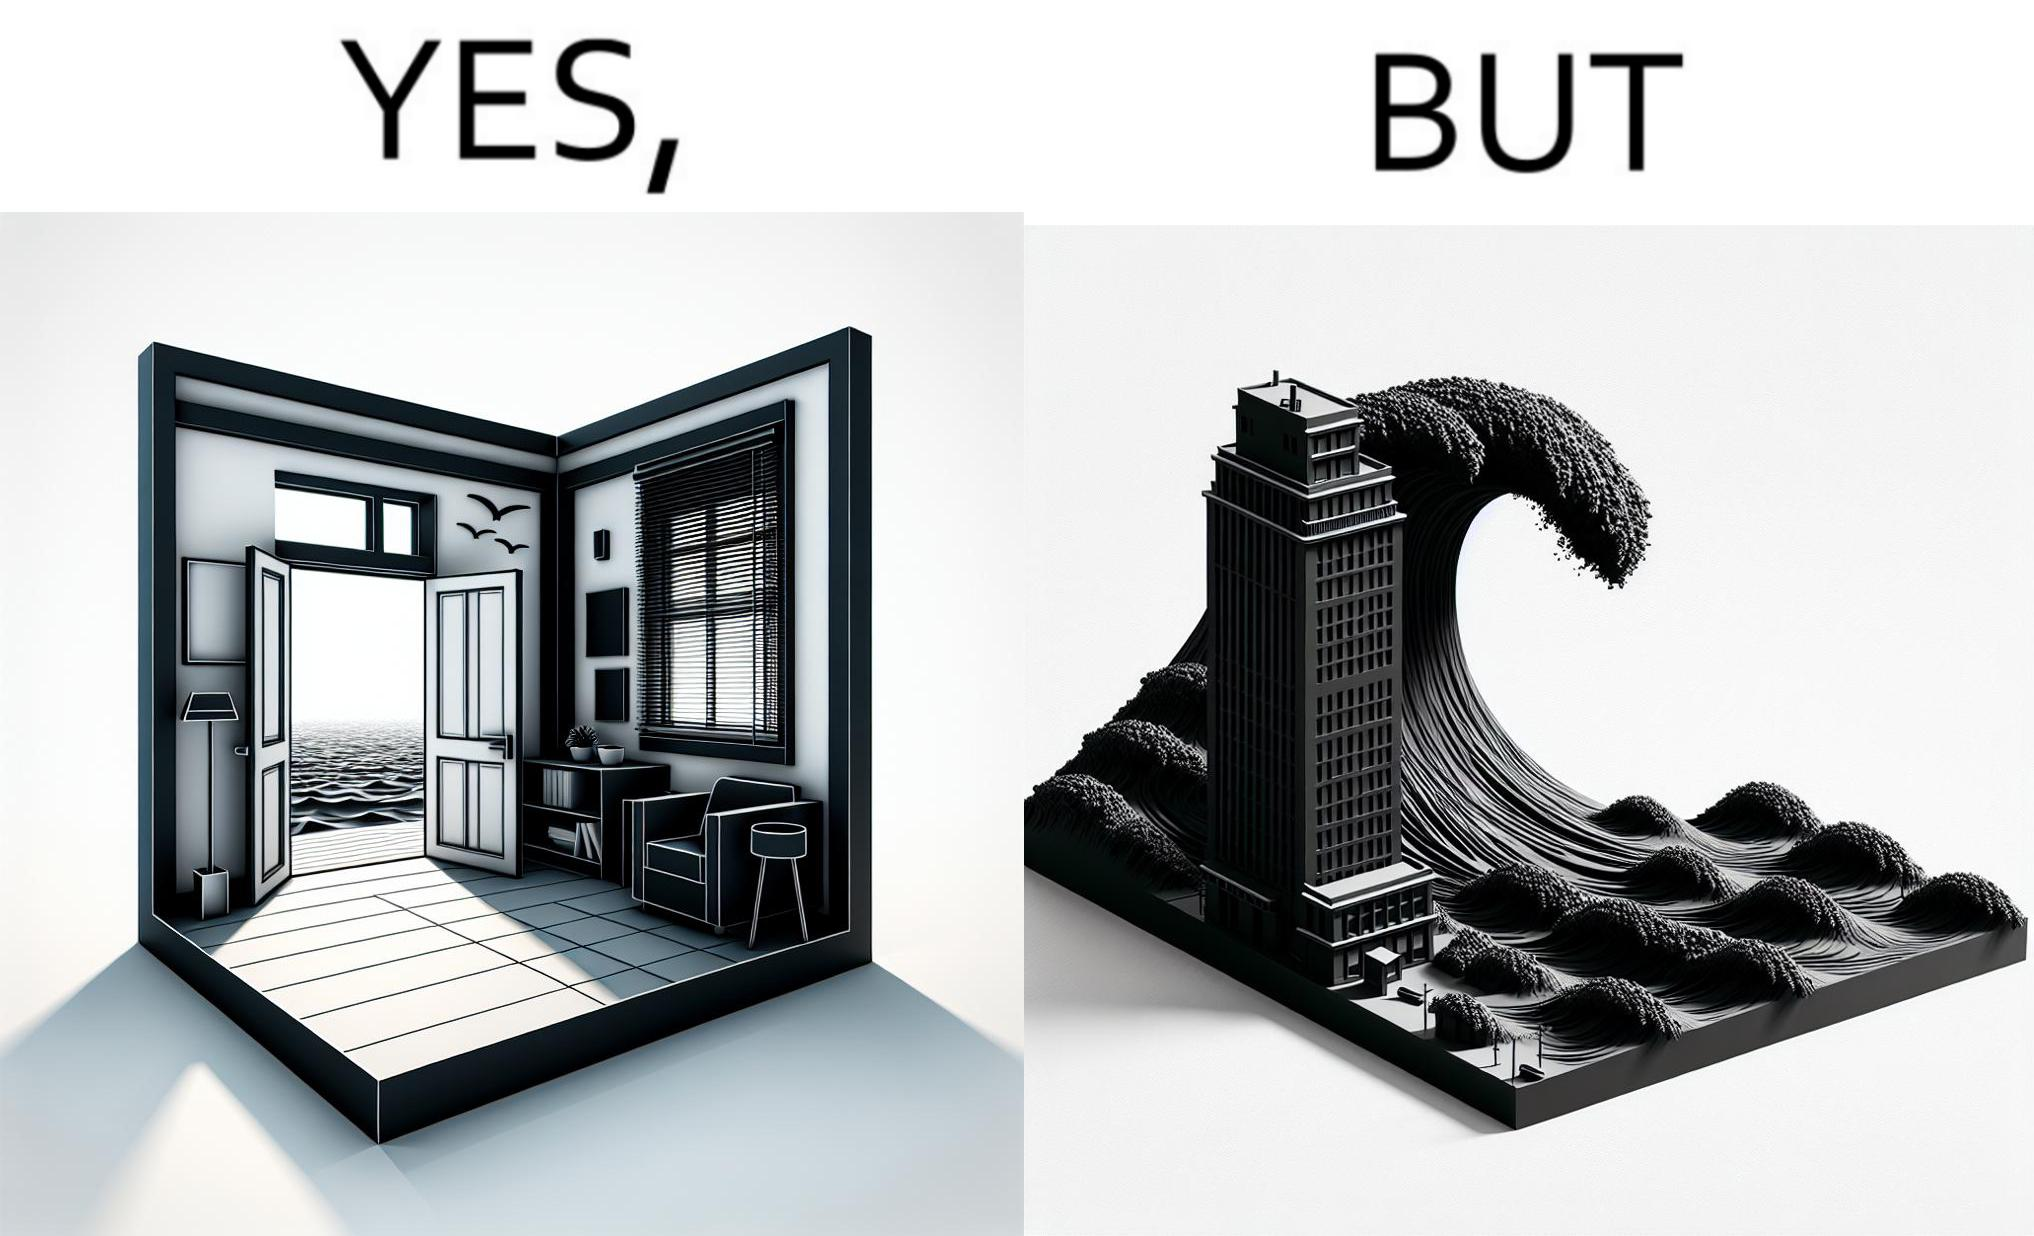Describe what you see in this image. The same sea which gives us a relaxation on a normal day can pose a danger to us sometimes like during a tsunami 